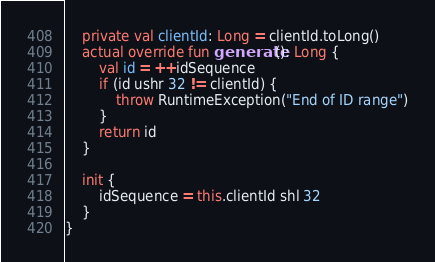<code> <loc_0><loc_0><loc_500><loc_500><_Kotlin_>    private val clientId: Long = clientId.toLong()
    actual override fun generate(): Long {
        val id = ++idSequence
        if (id ushr 32 != clientId) {
            throw RuntimeException("End of ID range")
        }
        return id
    }

    init {
        idSequence = this.clientId shl 32
    }
}
</code> 